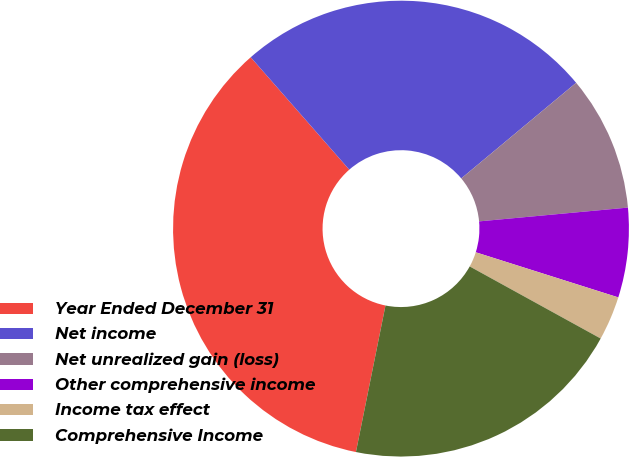Convert chart. <chart><loc_0><loc_0><loc_500><loc_500><pie_chart><fcel>Year Ended December 31<fcel>Net income<fcel>Net unrealized gain (loss)<fcel>Other comprehensive income<fcel>Income tax effect<fcel>Comprehensive Income<nl><fcel>35.38%<fcel>25.41%<fcel>9.58%<fcel>6.35%<fcel>3.13%<fcel>20.16%<nl></chart> 